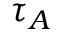<formula> <loc_0><loc_0><loc_500><loc_500>\tau _ { A }</formula> 